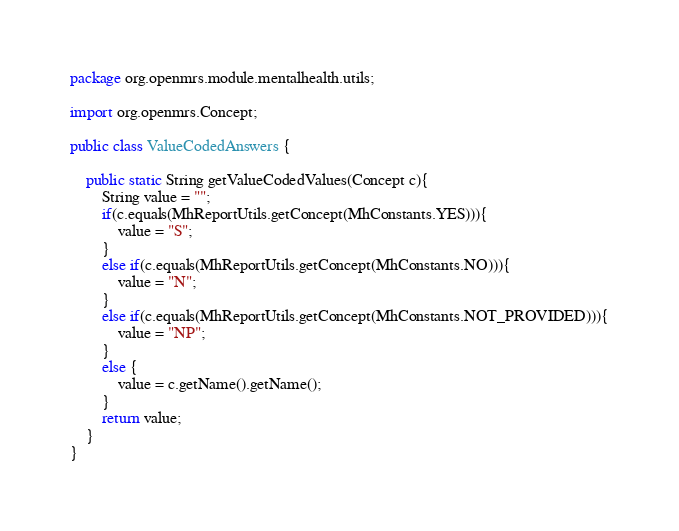<code> <loc_0><loc_0><loc_500><loc_500><_Java_>package org.openmrs.module.mentalhealth.utils;

import org.openmrs.Concept;

public class ValueCodedAnswers {

    public static String getValueCodedValues(Concept c){
        String value = "";
        if(c.equals(MhReportUtils.getConcept(MhConstants.YES))){
            value = "S";
        }
        else if(c.equals(MhReportUtils.getConcept(MhConstants.NO))){
            value = "N";
        }
        else if(c.equals(MhReportUtils.getConcept(MhConstants.NOT_PROVIDED))){
            value = "NP";
        }
        else {
            value = c.getName().getName();
        }
        return value;
    }
}
</code> 